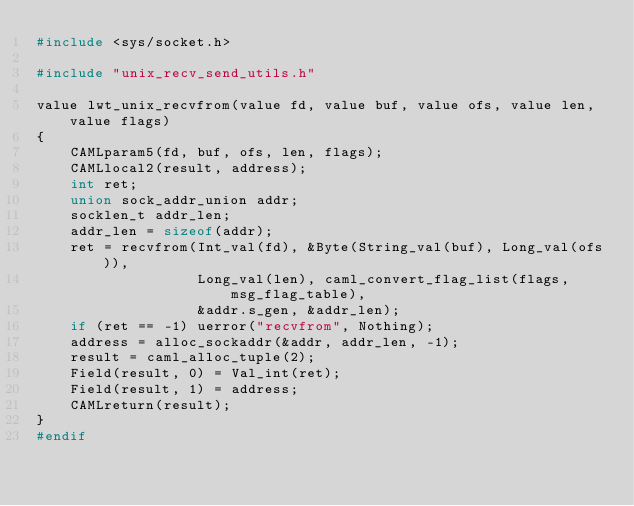<code> <loc_0><loc_0><loc_500><loc_500><_C_>#include <sys/socket.h>

#include "unix_recv_send_utils.h"

value lwt_unix_recvfrom(value fd, value buf, value ofs, value len, value flags)
{
    CAMLparam5(fd, buf, ofs, len, flags);
    CAMLlocal2(result, address);
    int ret;
    union sock_addr_union addr;
    socklen_t addr_len;
    addr_len = sizeof(addr);
    ret = recvfrom(Int_val(fd), &Byte(String_val(buf), Long_val(ofs)),
                   Long_val(len), caml_convert_flag_list(flags, msg_flag_table),
                   &addr.s_gen, &addr_len);
    if (ret == -1) uerror("recvfrom", Nothing);
    address = alloc_sockaddr(&addr, addr_len, -1);
    result = caml_alloc_tuple(2);
    Field(result, 0) = Val_int(ret);
    Field(result, 1) = address;
    CAMLreturn(result);
}
#endif
</code> 